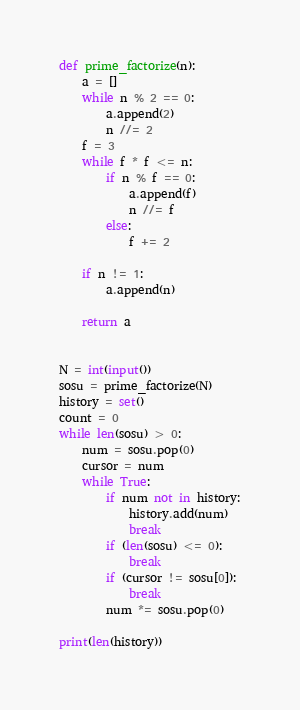<code> <loc_0><loc_0><loc_500><loc_500><_Python_>def prime_factorize(n):
    a = []
    while n % 2 == 0:
        a.append(2)
        n //= 2
    f = 3
    while f * f <= n:
        if n % f == 0:
            a.append(f)
            n //= f
        else:
            f += 2

    if n != 1:
        a.append(n)

    return a


N = int(input())
sosu = prime_factorize(N)
history = set()
count = 0
while len(sosu) > 0:
    num = sosu.pop(0)
    cursor = num
    while True:
        if num not in history:
            history.add(num)
            break
        if (len(sosu) <= 0):
            break
        if (cursor != sosu[0]):
            break
        num *= sosu.pop(0)

print(len(history))
</code> 